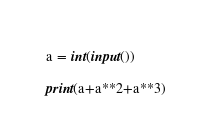Convert code to text. <code><loc_0><loc_0><loc_500><loc_500><_Python_>a = int(input())

print(a+a**2+a**3)</code> 